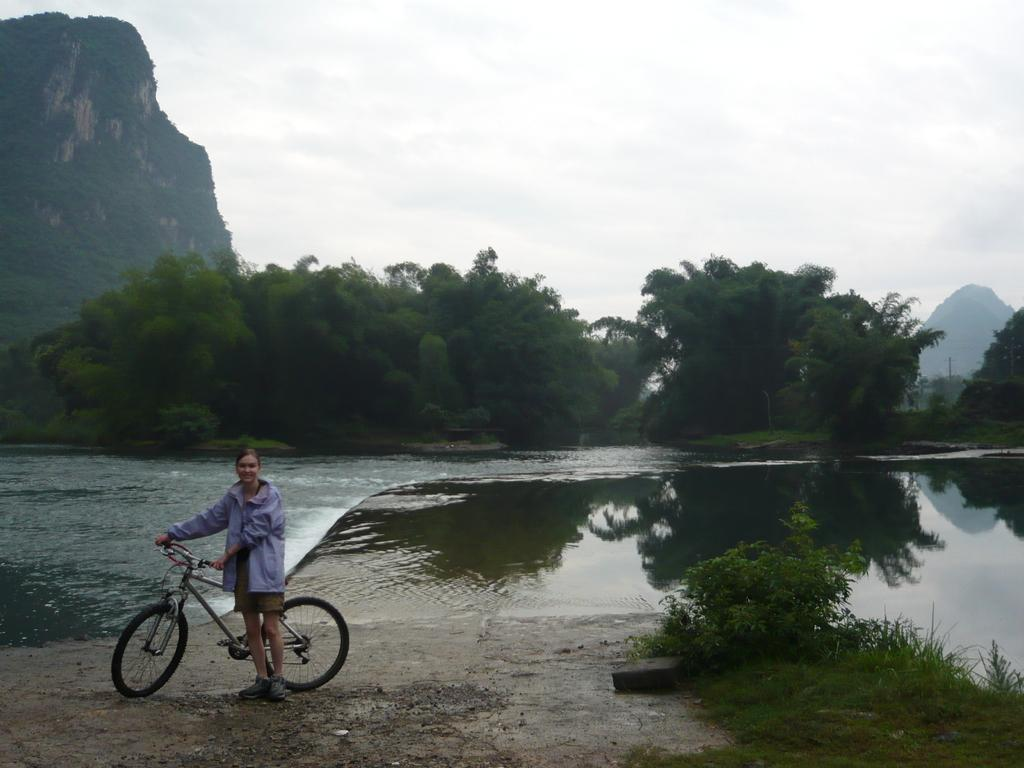Where was the image taken? The image was clicked outside. What can be seen in the image besides the person with a cycle? There are trees and water visible in the image. What is the background of the image? The sky is visible at the top of the image. What type of bread can be seen in the image? There is no bread present in the image. How does the harmony of the environment contribute to the image? The concept of harmony is not mentioned or depicted in the image, as it features a person with a cycle, trees, water, and the sky. 